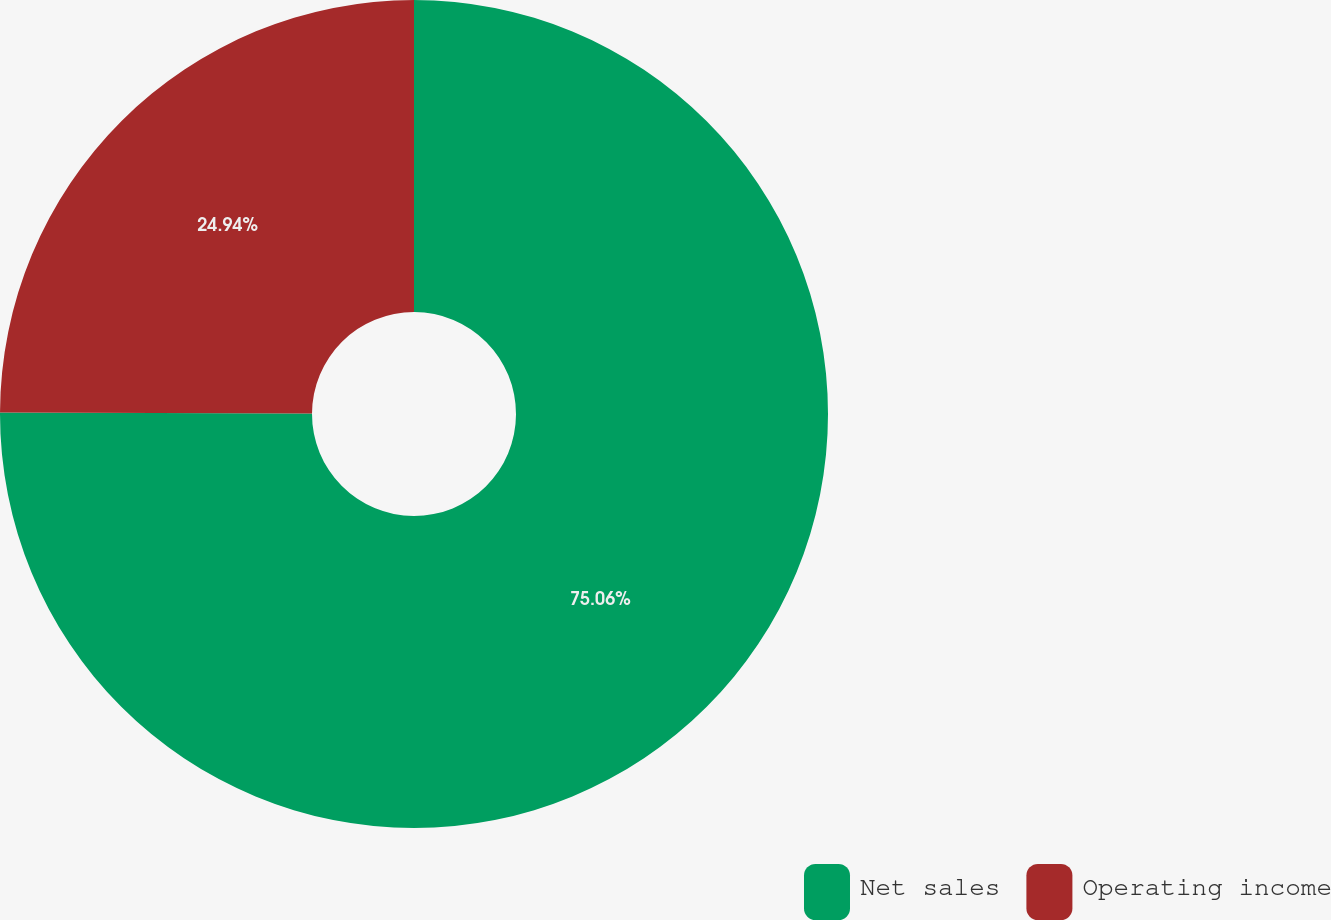<chart> <loc_0><loc_0><loc_500><loc_500><pie_chart><fcel>Net sales<fcel>Operating income<nl><fcel>75.06%<fcel>24.94%<nl></chart> 